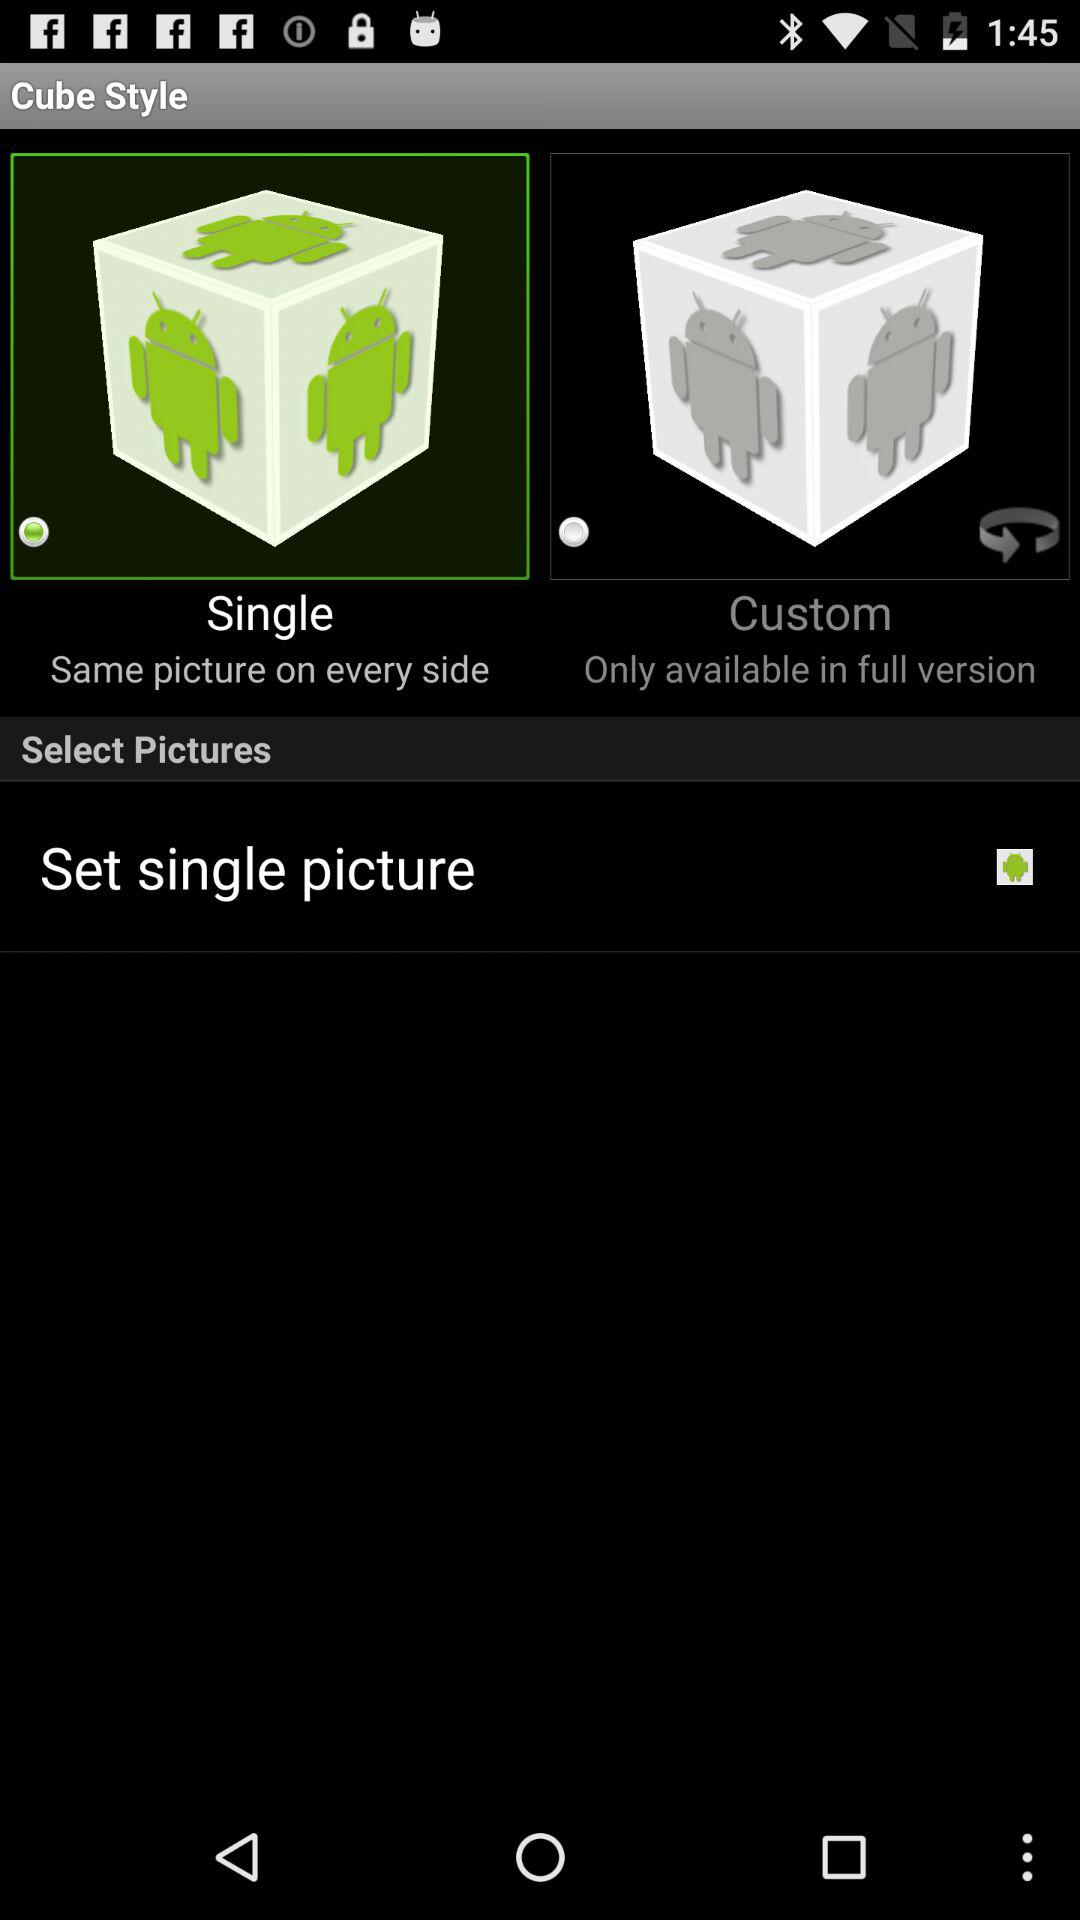How many options are available for the cube style?
Answer the question using a single word or phrase. 2 